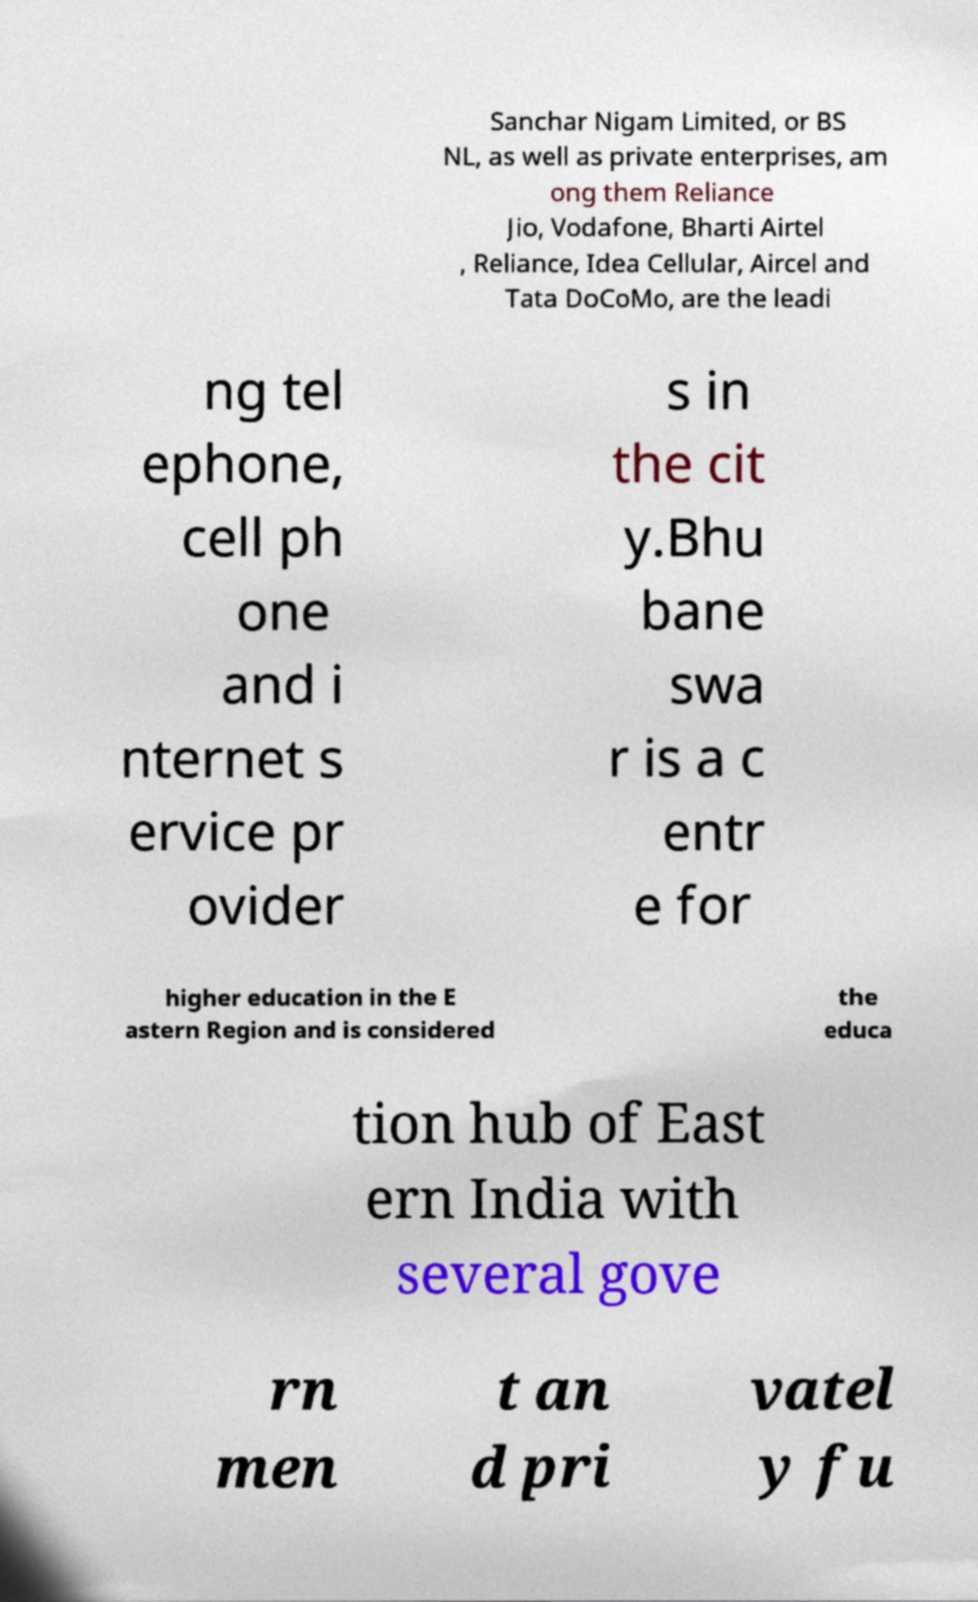Please read and relay the text visible in this image. What does it say? Sanchar Nigam Limited, or BS NL, as well as private enterprises, am ong them Reliance Jio, Vodafone, Bharti Airtel , Reliance, Idea Cellular, Aircel and Tata DoCoMo, are the leadi ng tel ephone, cell ph one and i nternet s ervice pr ovider s in the cit y.Bhu bane swa r is a c entr e for higher education in the E astern Region and is considered the educa tion hub of East ern India with several gove rn men t an d pri vatel y fu 